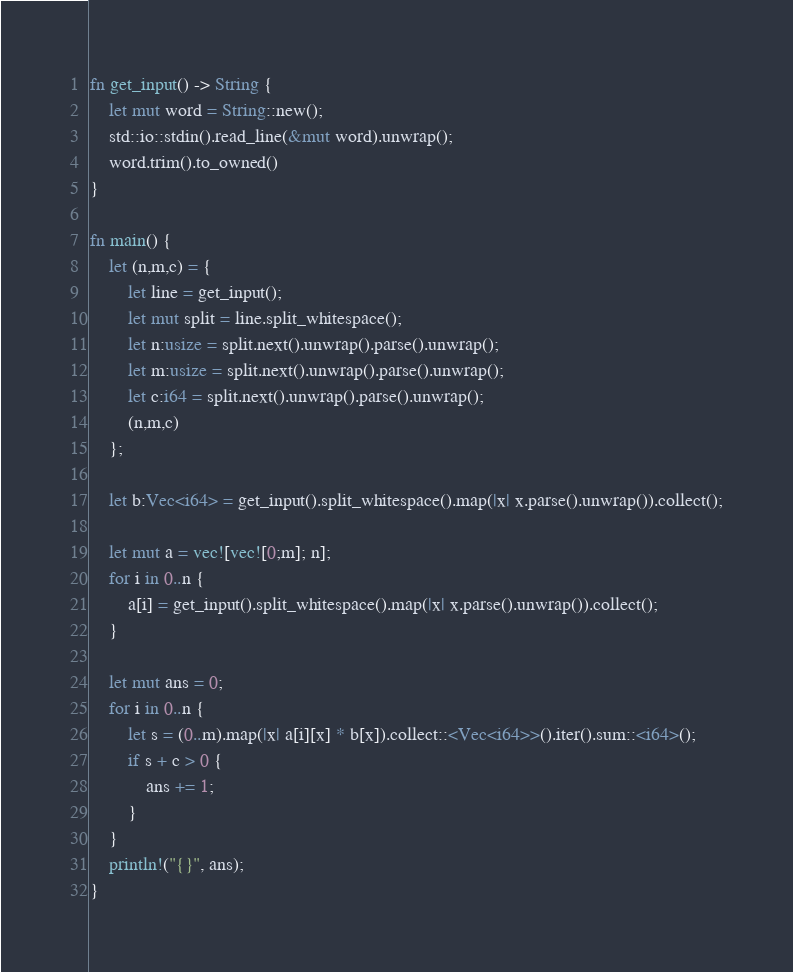<code> <loc_0><loc_0><loc_500><loc_500><_Rust_>fn get_input() -> String {
    let mut word = String::new();
    std::io::stdin().read_line(&mut word).unwrap();
    word.trim().to_owned()
}

fn main() {
    let (n,m,c) = {
        let line = get_input();
        let mut split = line.split_whitespace();
        let n:usize = split.next().unwrap().parse().unwrap();
        let m:usize = split.next().unwrap().parse().unwrap();
        let c:i64 = split.next().unwrap().parse().unwrap();
        (n,m,c)
    };

    let b:Vec<i64> = get_input().split_whitespace().map(|x| x.parse().unwrap()).collect();

    let mut a = vec![vec![0;m]; n];
    for i in 0..n {
        a[i] = get_input().split_whitespace().map(|x| x.parse().unwrap()).collect();
    }

    let mut ans = 0;
    for i in 0..n {
        let s = (0..m).map(|x| a[i][x] * b[x]).collect::<Vec<i64>>().iter().sum::<i64>();
        if s + c > 0 {
            ans += 1;
        }
    }
    println!("{}", ans);
}</code> 